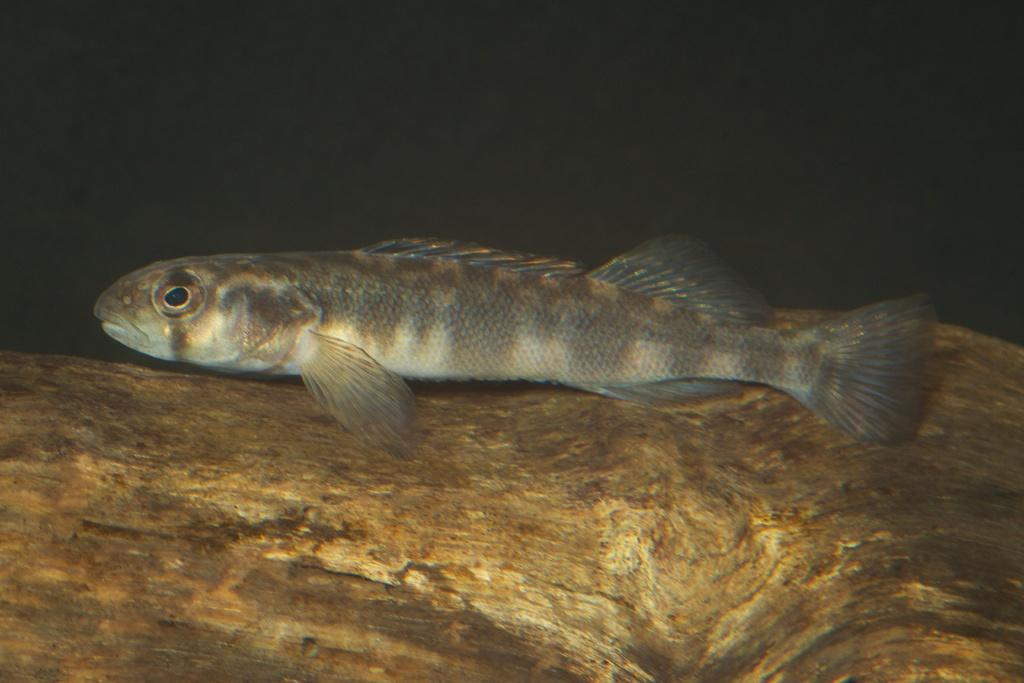What type of animal is in the image? There is a fish in the image. Where is the fish located? The fish is in water. What type of lace is the fish wearing in the image? There is no lace present in the image, and the fish is not wearing any clothing. 